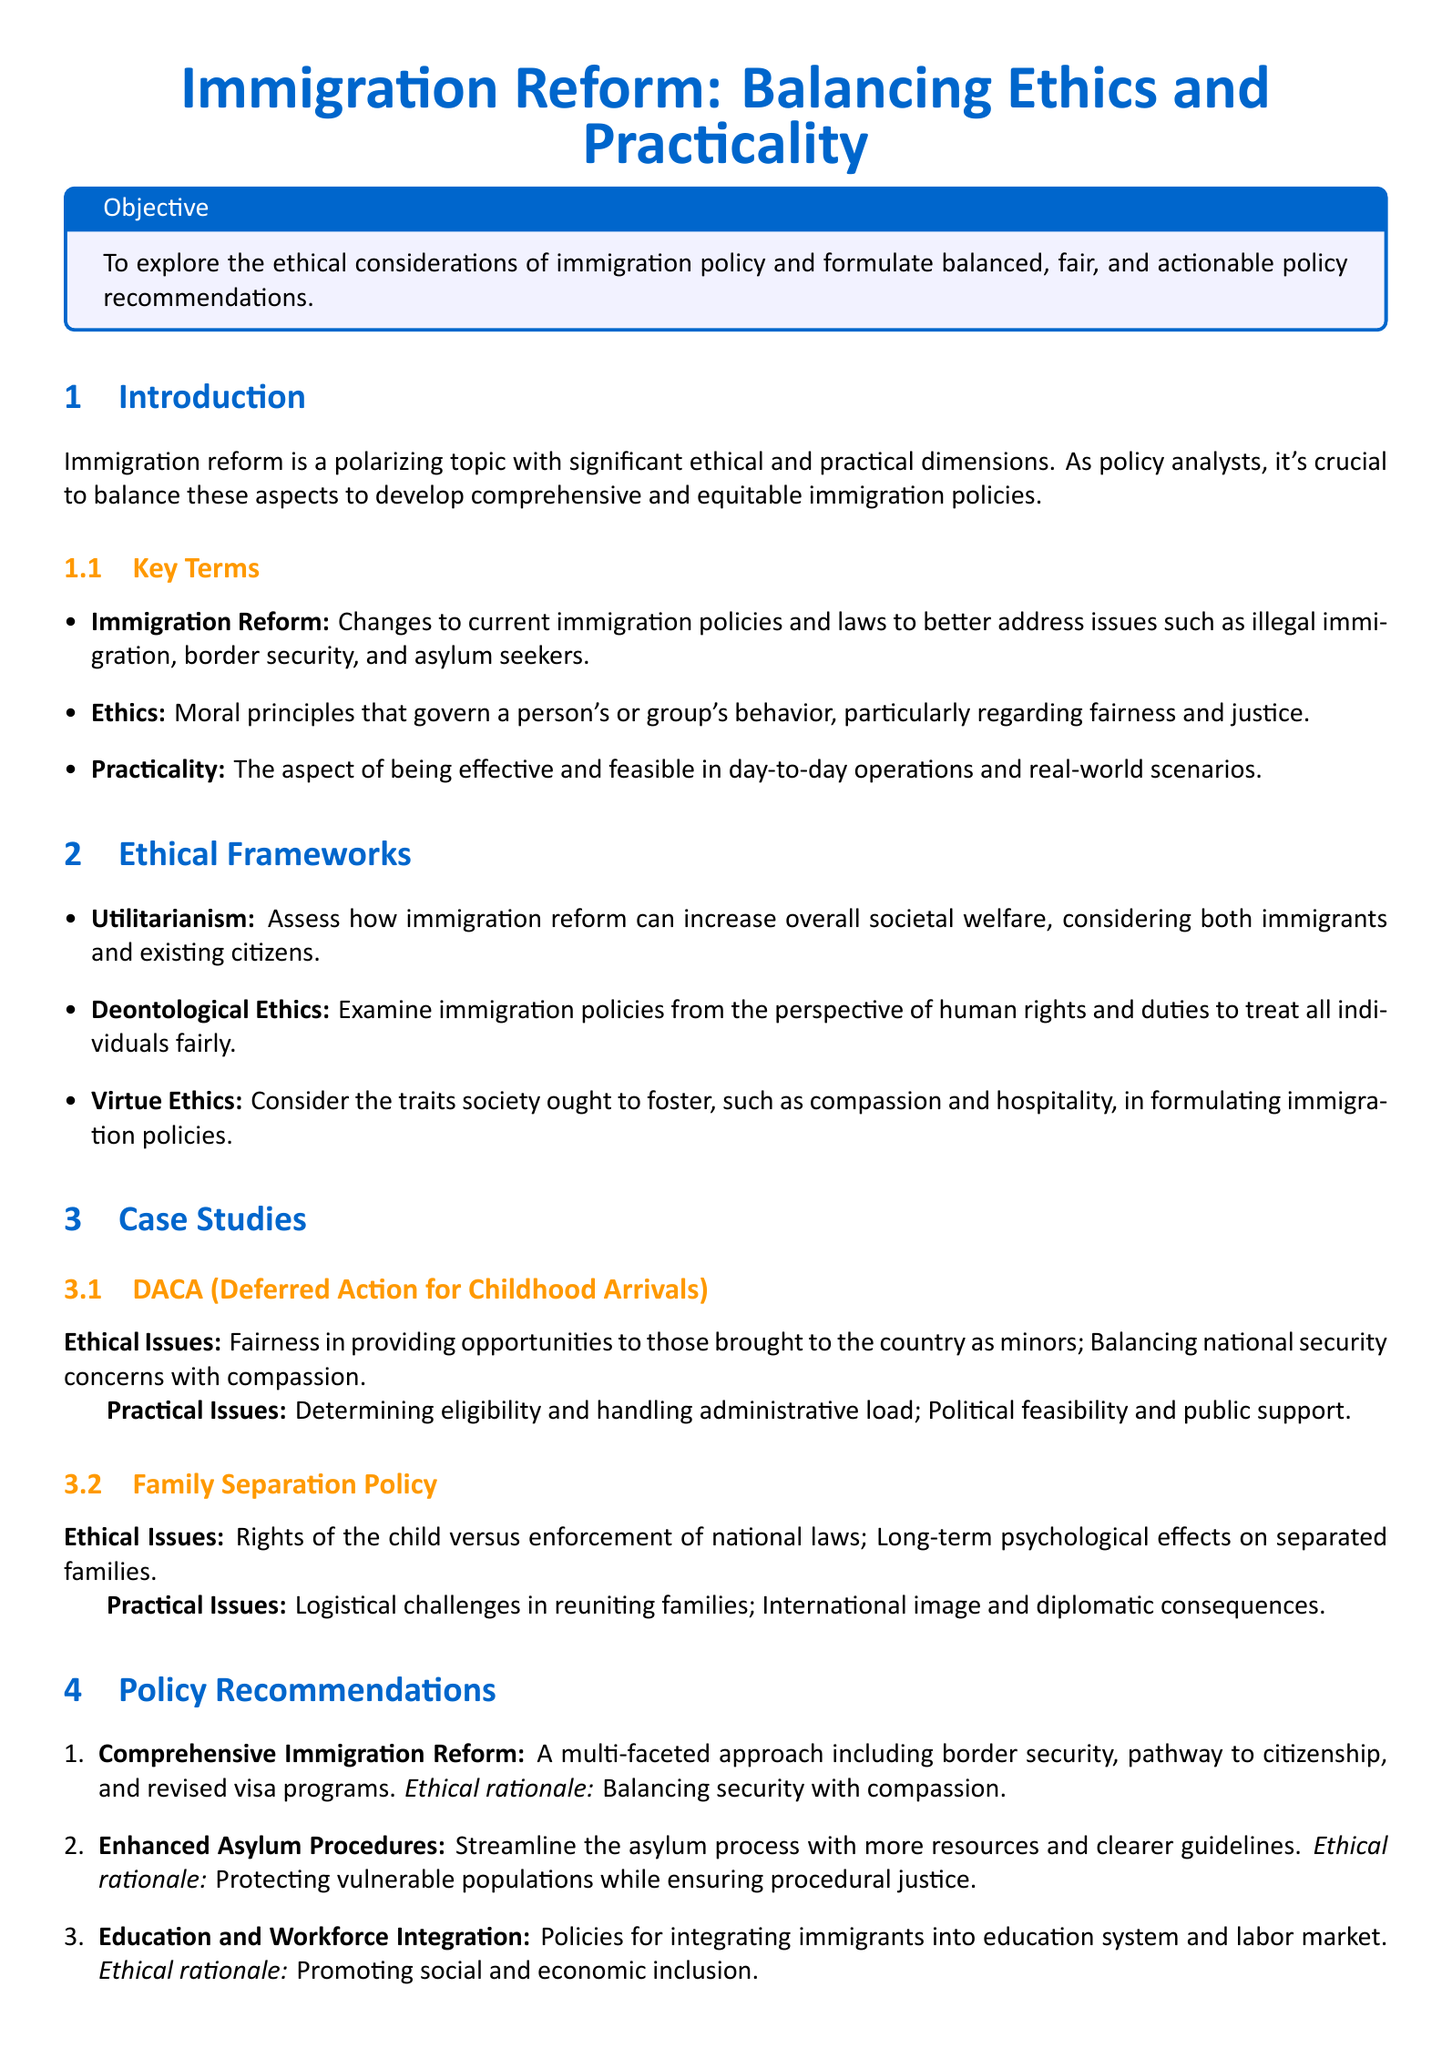What is the title of the lesson plan? The title of the lesson plan is stated prominently at the beginning of the document.
Answer: Immigration Reform: Balancing Ethics and Practicality What is the objective of the lesson plan? The objective is clearly outlined in a dedicated box within the document.
Answer: To explore the ethical considerations of immigration policy and formulate balanced, fair, and actionable policy recommendations What ethical framework emphasizes overall societal welfare? This framework is specifically mentioned in the section discussing ethical frameworks.
Answer: Utilitarianism What case study addresses fairness in providing opportunities to those brought to the country as minors? This case study is presented in the section detailing specific immigration issues.
Answer: DACA (Deferred Action for Childhood Arrivals) What is one of the practical issues associated with the Family Separation Policy? This information is provided under the practical issues section for that case study.
Answer: Logistical challenges in reuniting families How many policy recommendations are provided in the document? The number of recommendations is listed in the policy recommendations section.
Answer: Three What is the ethical rationale for enhanced asylum procedures? The rationale is mentioned alongside the policy recommendation in the document.
Answer: Protecting vulnerable populations while ensuring procedural justice What does the term "Immigration Reform" refer to? The definition is provided in the key terms section of the document.
Answer: Changes to current immigration policies and laws to better address issues such as illegal immigration, border security, and asylum seekers 